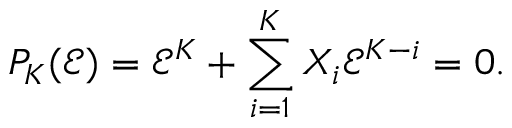<formula> <loc_0><loc_0><loc_500><loc_500>P _ { K } ( \mathcal { E } ) = \mathcal { E } ^ { K } + \sum _ { i = 1 } ^ { K } X _ { i } \mathcal { E } ^ { K - i } = 0 .</formula> 